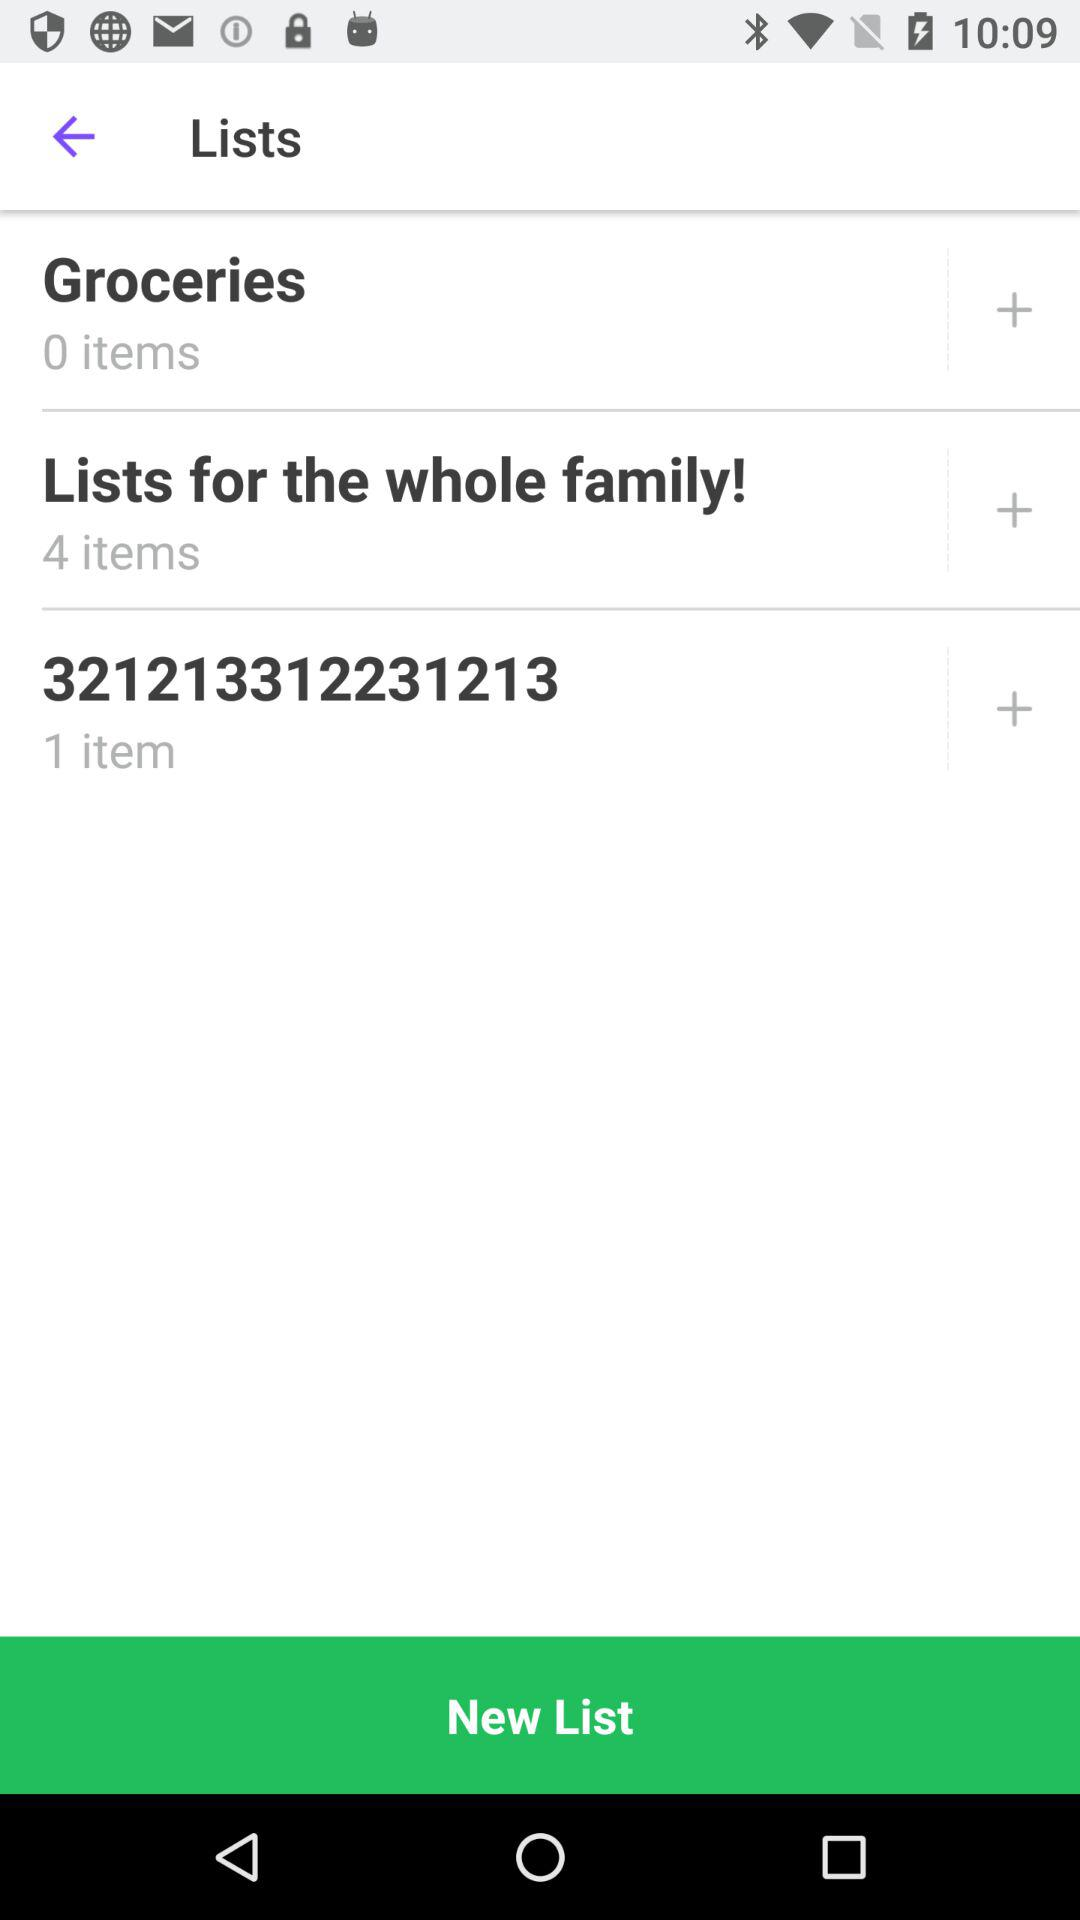How many items are there in the "Lists for the whole family!"? There are 4 items in the "Lists for the whole family!". 